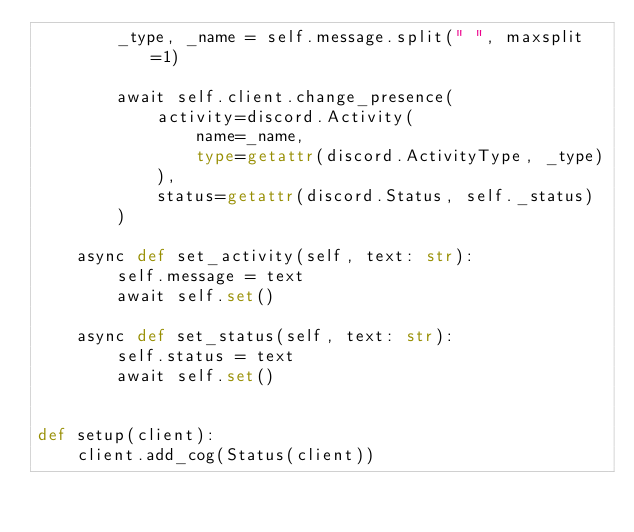<code> <loc_0><loc_0><loc_500><loc_500><_Python_>        _type, _name = self.message.split(" ", maxsplit=1)

        await self.client.change_presence(
            activity=discord.Activity(
                name=_name,
                type=getattr(discord.ActivityType, _type)
            ),
            status=getattr(discord.Status, self._status)
        )

    async def set_activity(self, text: str):
        self.message = text
        await self.set()

    async def set_status(self, text: str):
        self.status = text
        await self.set()


def setup(client):
    client.add_cog(Status(client))
</code> 